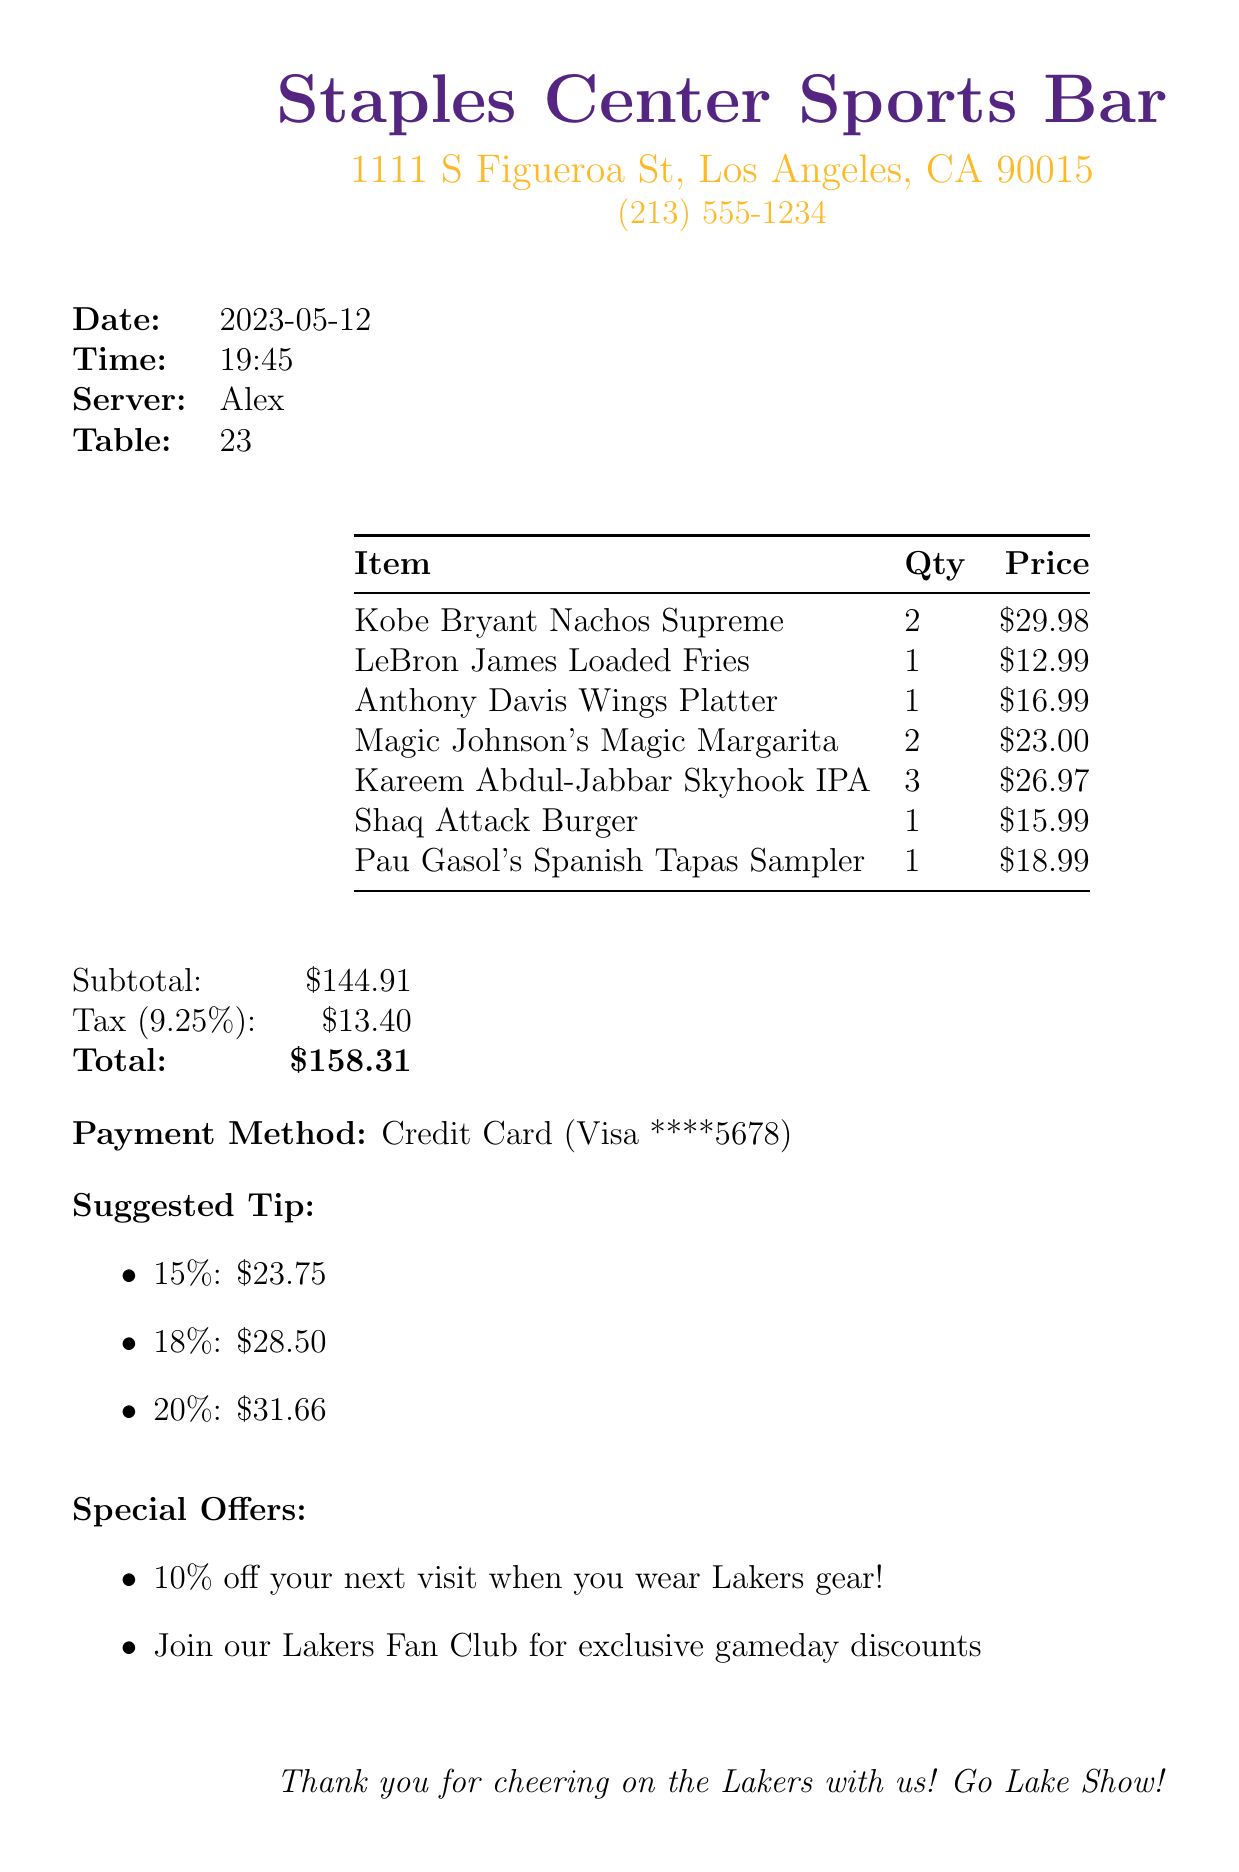What is the name of the restaurant? The restaurant name is clearly stated at the top of the document.
Answer: Staples Center Sports Bar What is the date of the transaction? The date of the transaction is mentioned in the document.
Answer: 2023-05-12 Who was the server? The name of the server is provided in the details section of the document.
Answer: Alex What is the total amount due? The total amount due is stated at the end of the receipt.
Answer: $158.31 How many types of beer were ordered? The number of beer items in the receipt falls under the beverage category.
Answer: 1 What is the price of the Shaq Attack Burger? The price of the specific item is listed in the itemized table.
Answer: $15.99 What is the subtotal before tax? The subtotal amount is provided before tax calculations.
Answer: $144.91 What special offer is mentioned? The special offers section lists promotional offers for Lakers fans.
Answer: 10% off your next visit when you wear Lakers gear! What is the tax rate applied? The tax rate is indicated in the tax calculation section of the receipt.
Answer: 9.25% 